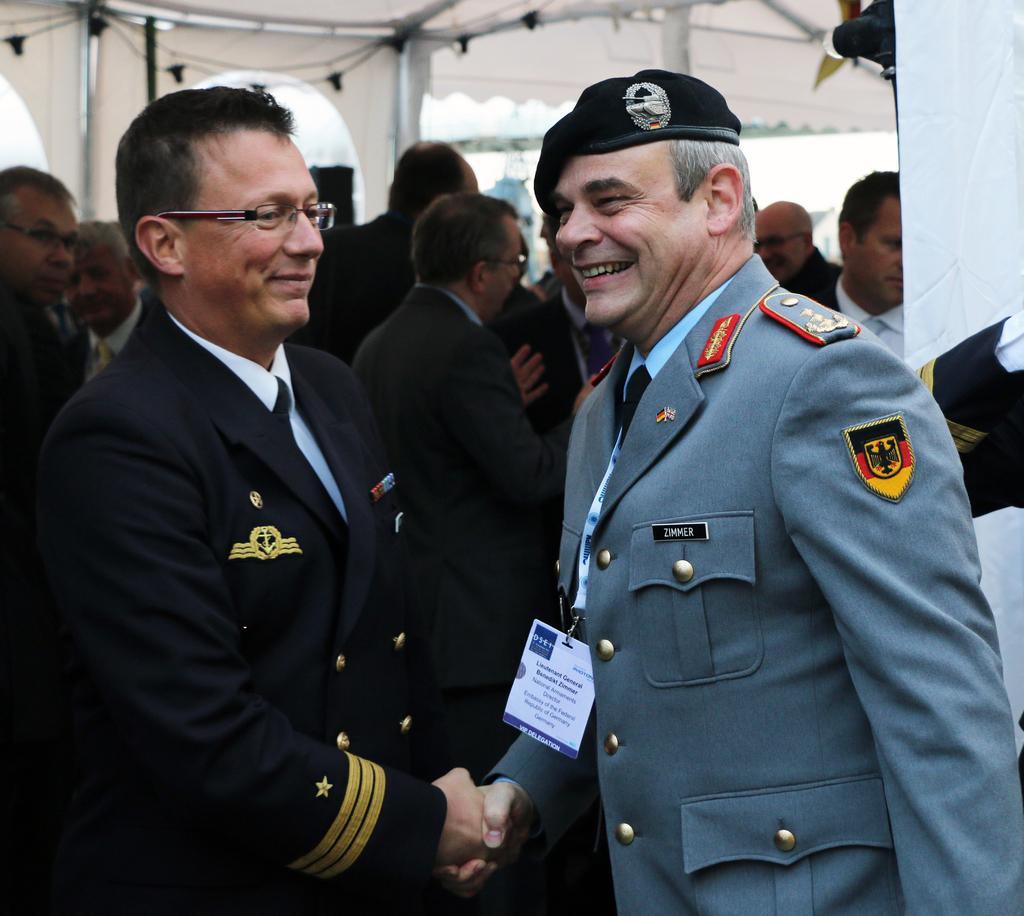Please provide a concise description of this image. There are two men standing and smiling. They are handshaking each other. In the background, I can see a group of people standing. I think this is a tent. 